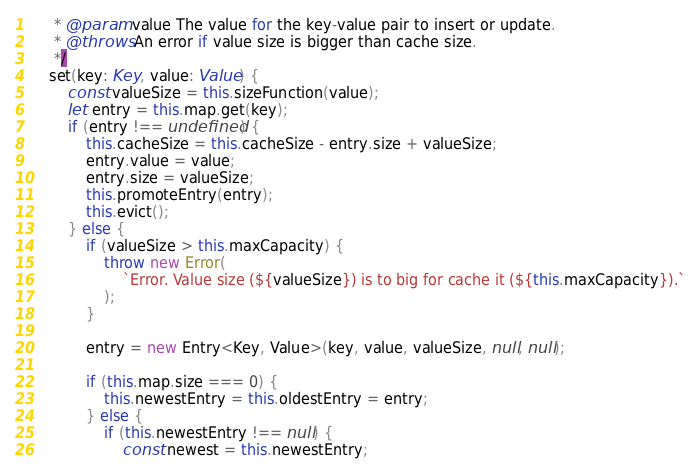<code> <loc_0><loc_0><loc_500><loc_500><_TypeScript_>     * @param value The value for the key-value pair to insert or update.
     * @throws An error if value size is bigger than cache size.
     */
    set(key: Key, value: Value) {
        const valueSize = this.sizeFunction(value);
        let entry = this.map.get(key);
        if (entry !== undefined) {
            this.cacheSize = this.cacheSize - entry.size + valueSize;
            entry.value = value;
            entry.size = valueSize;
            this.promoteEntry(entry);
            this.evict();
        } else {
            if (valueSize > this.maxCapacity) {
                throw new Error(
                    `Error. Value size (${valueSize}) is to big for cache it (${this.maxCapacity}).`
                );
            }

            entry = new Entry<Key, Value>(key, value, valueSize, null, null);

            if (this.map.size === 0) {
                this.newestEntry = this.oldestEntry = entry;
            } else {
                if (this.newestEntry !== null) {
                    const newest = this.newestEntry;
</code> 